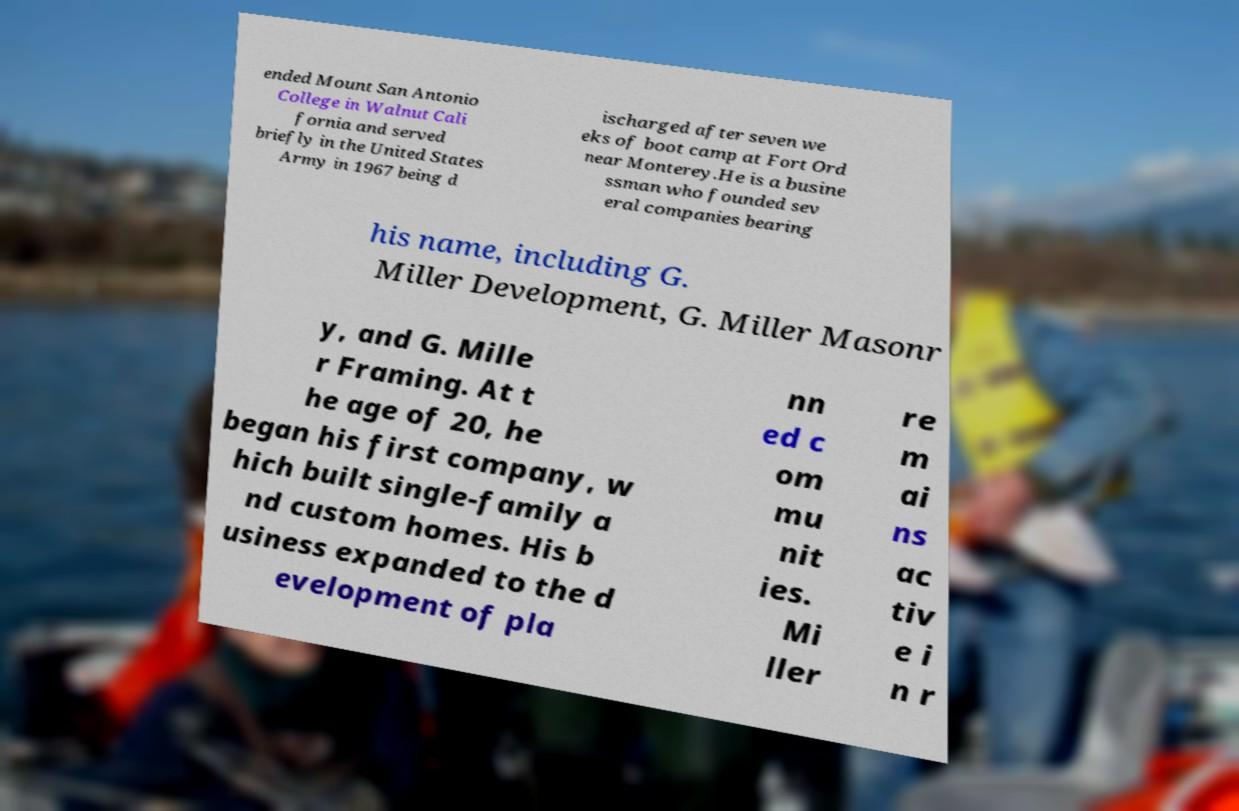What messages or text are displayed in this image? I need them in a readable, typed format. ended Mount San Antonio College in Walnut Cali fornia and served briefly in the United States Army in 1967 being d ischarged after seven we eks of boot camp at Fort Ord near Monterey.He is a busine ssman who founded sev eral companies bearing his name, including G. Miller Development, G. Miller Masonr y, and G. Mille r Framing. At t he age of 20, he began his first company, w hich built single-family a nd custom homes. His b usiness expanded to the d evelopment of pla nn ed c om mu nit ies. Mi ller re m ai ns ac tiv e i n r 